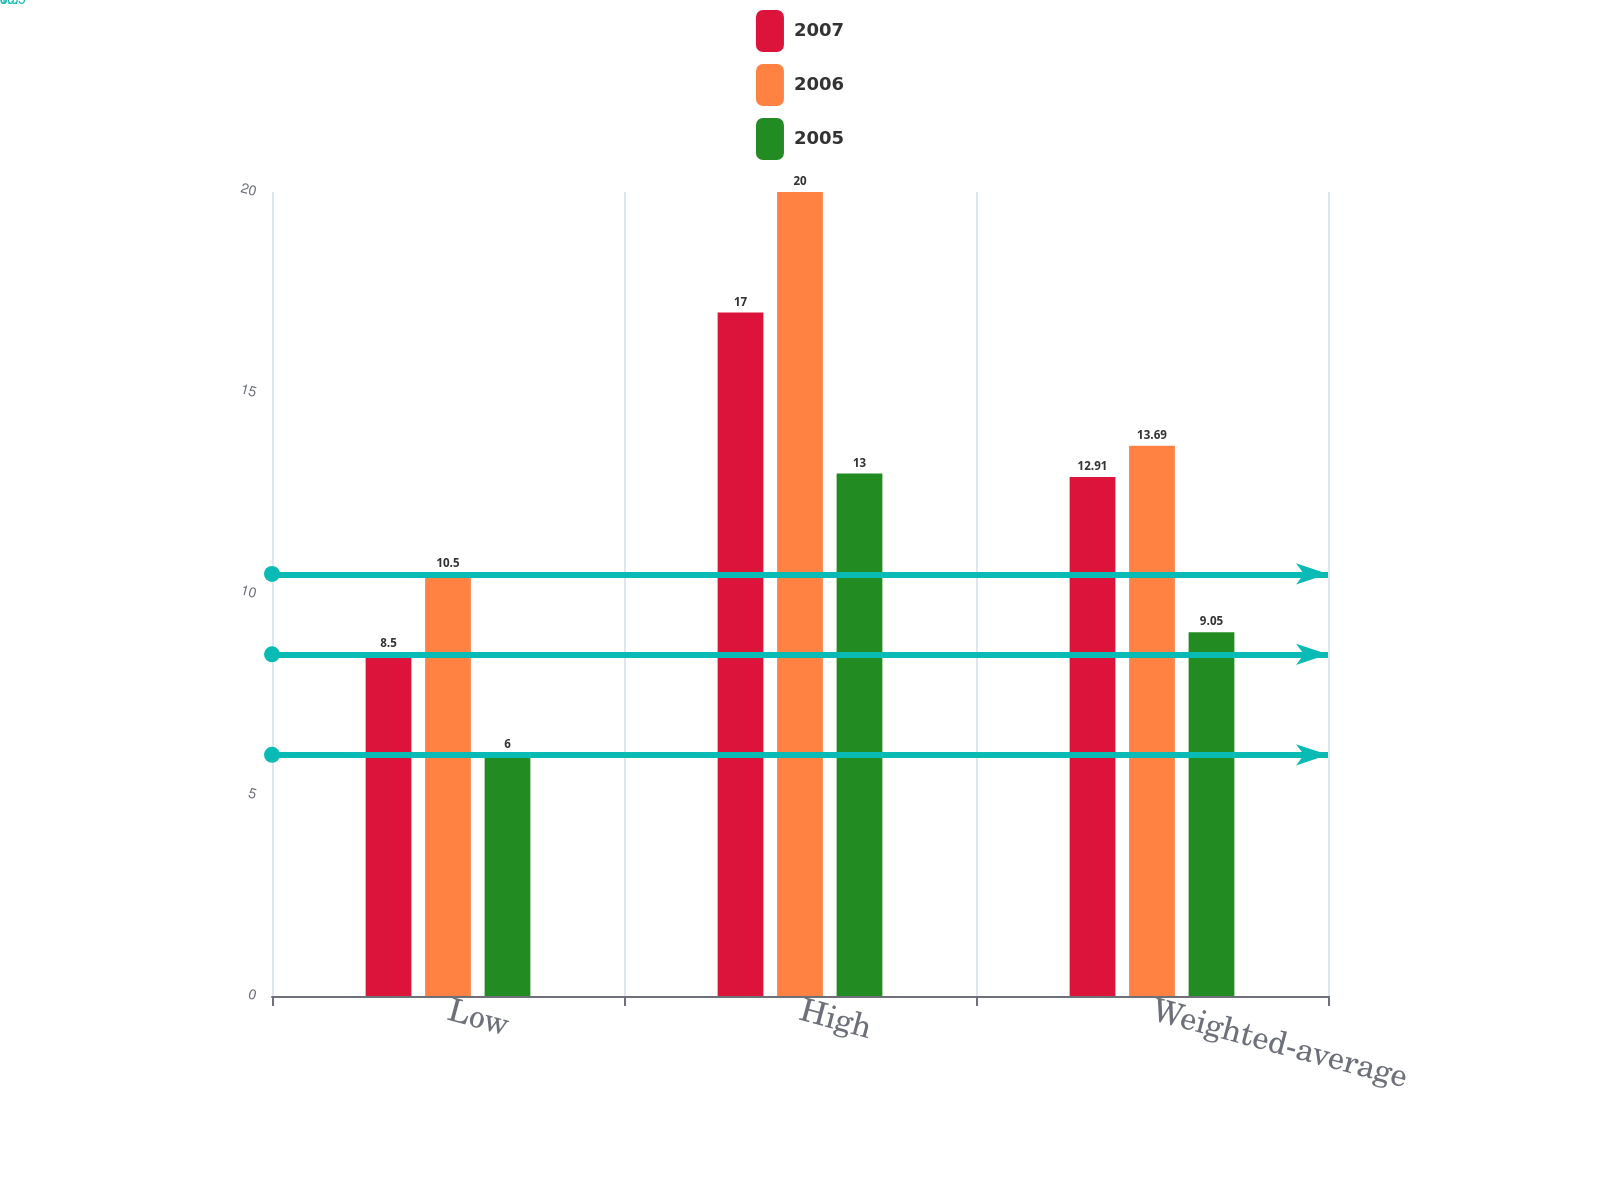Convert chart. <chart><loc_0><loc_0><loc_500><loc_500><stacked_bar_chart><ecel><fcel>Low<fcel>High<fcel>Weighted-average<nl><fcel>2007<fcel>8.5<fcel>17<fcel>12.91<nl><fcel>2006<fcel>10.5<fcel>20<fcel>13.69<nl><fcel>2005<fcel>6<fcel>13<fcel>9.05<nl></chart> 